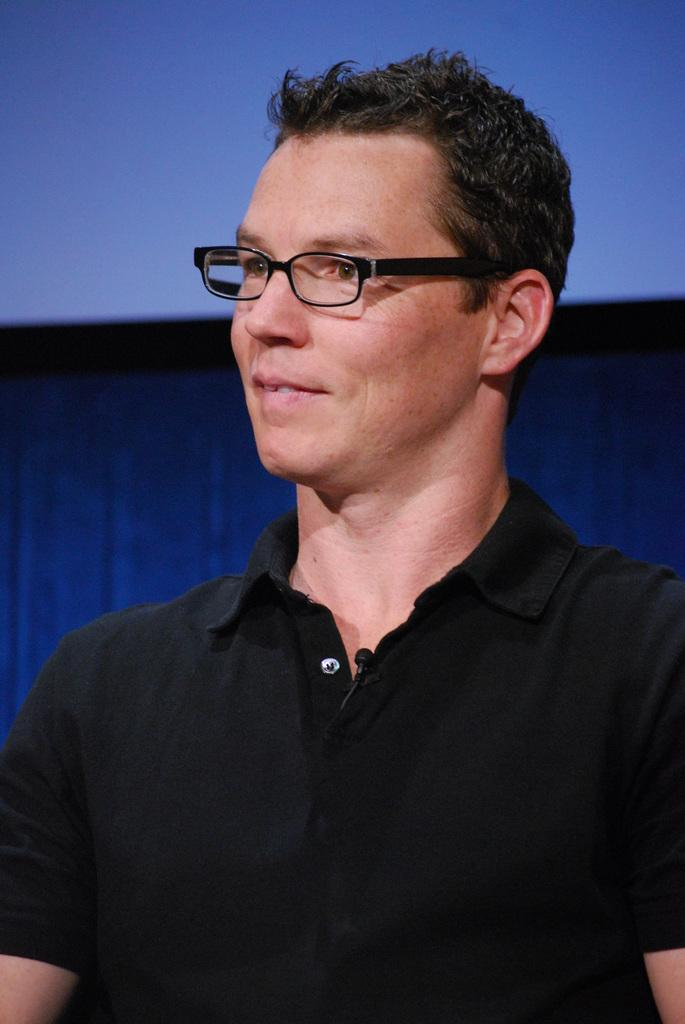What is the main subject of the image? There is a person in the image. What is the person wearing in the image? The person is wearing a black-colored dress and spectacles. What colors can be seen in the background of the image? The background of the image is blue and black colored. Can you tell me how many stamps are on the person's cap in the image? There is no cap or stamp present in the image. What type of crate is visible in the background of the image? There is no crate present in the image; the background is blue and black colored. 